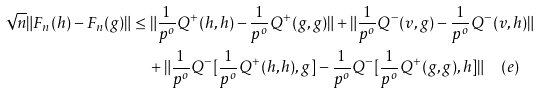Convert formula to latex. <formula><loc_0><loc_0><loc_500><loc_500>\sqrt { n } \| F _ { n } ( h ) - F _ { n } ( g ) \| & \leq \| \frac { 1 } { p ^ { o } } Q ^ { + } ( h , h ) - \frac { 1 } { p ^ { o } } Q ^ { + } ( g , g ) \| + \| \frac { 1 } { p ^ { o } } Q ^ { - } ( v , g ) - \frac { 1 } { p ^ { o } } Q ^ { - } ( v , h ) \| \\ & \quad + \| \frac { 1 } { p ^ { o } } Q ^ { - } [ \frac { 1 } { p ^ { o } } Q ^ { + } ( h , h ) , g ] - \frac { 1 } { p ^ { o } } Q ^ { - } [ \frac { 1 } { p ^ { o } } Q ^ { + } ( g , g ) , h ] \| \quad ( e )</formula> 